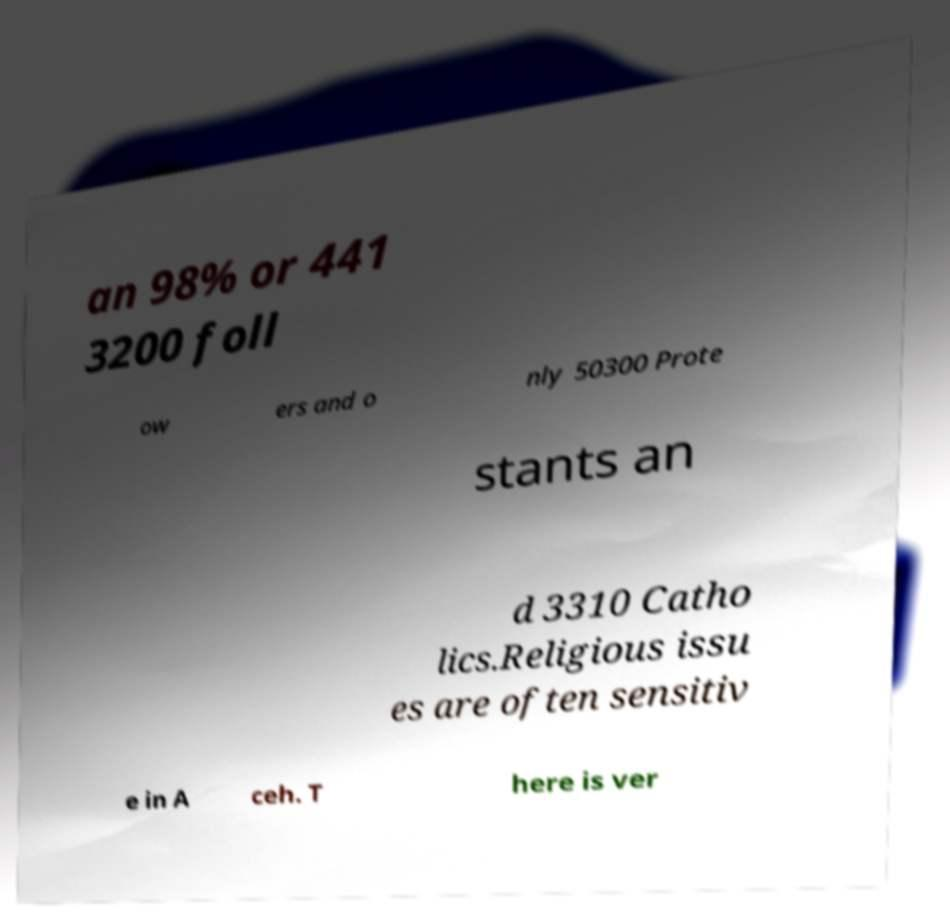Please identify and transcribe the text found in this image. an 98% or 441 3200 foll ow ers and o nly 50300 Prote stants an d 3310 Catho lics.Religious issu es are often sensitiv e in A ceh. T here is ver 